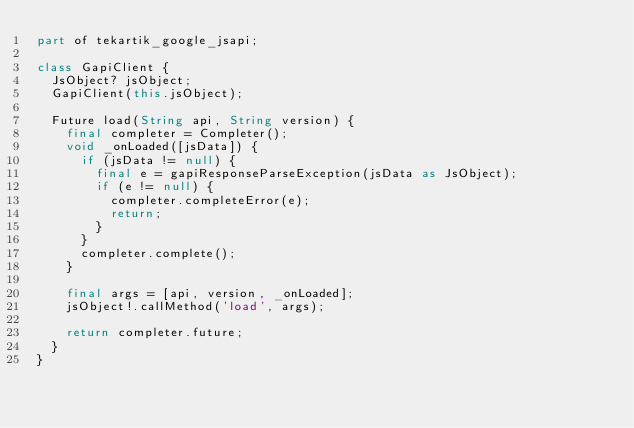<code> <loc_0><loc_0><loc_500><loc_500><_Dart_>part of tekartik_google_jsapi;

class GapiClient {
  JsObject? jsObject;
  GapiClient(this.jsObject);

  Future load(String api, String version) {
    final completer = Completer();
    void _onLoaded([jsData]) {
      if (jsData != null) {
        final e = gapiResponseParseException(jsData as JsObject);
        if (e != null) {
          completer.completeError(e);
          return;
        }
      }
      completer.complete();
    }

    final args = [api, version, _onLoaded];
    jsObject!.callMethod('load', args);

    return completer.future;
  }
}
</code> 